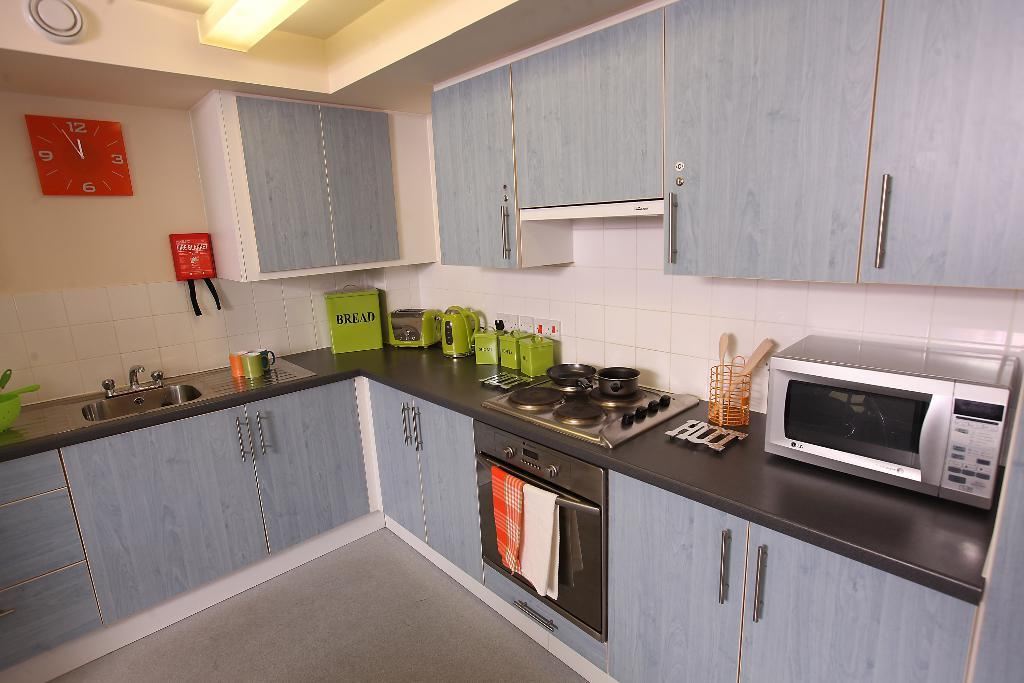<image>
Give a short and clear explanation of the subsequent image. A green Bread box sits next to a green toaster on a dark gray kitchen counter with blue cabinets. 